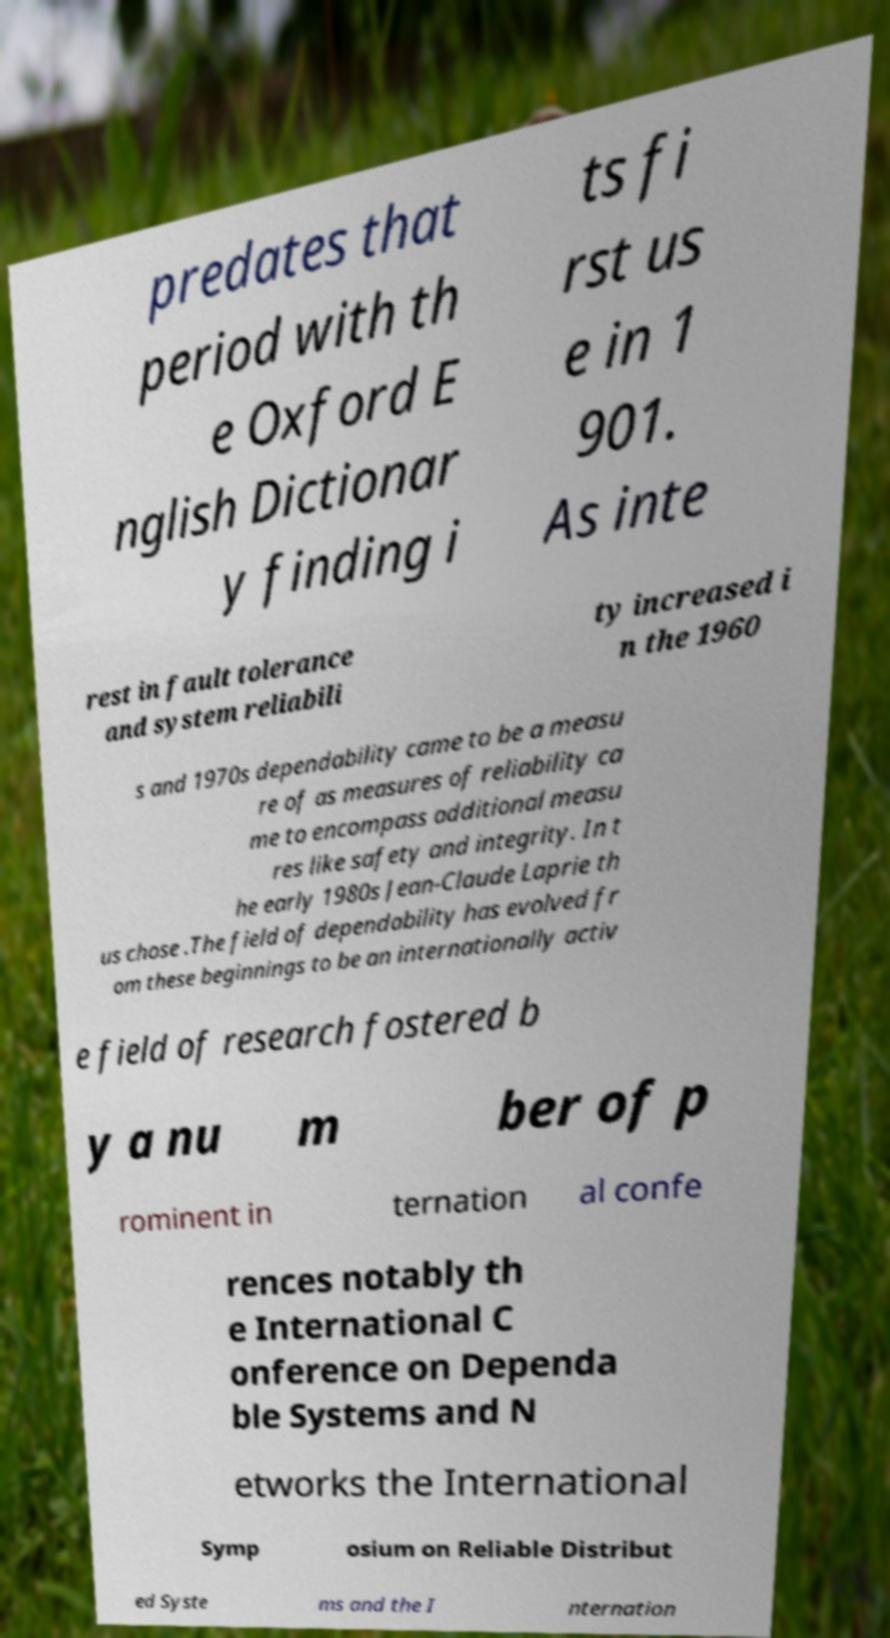Please identify and transcribe the text found in this image. predates that period with th e Oxford E nglish Dictionar y finding i ts fi rst us e in 1 901. As inte rest in fault tolerance and system reliabili ty increased i n the 1960 s and 1970s dependability came to be a measu re of as measures of reliability ca me to encompass additional measu res like safety and integrity. In t he early 1980s Jean-Claude Laprie th us chose .The field of dependability has evolved fr om these beginnings to be an internationally activ e field of research fostered b y a nu m ber of p rominent in ternation al confe rences notably th e International C onference on Dependa ble Systems and N etworks the International Symp osium on Reliable Distribut ed Syste ms and the I nternation 